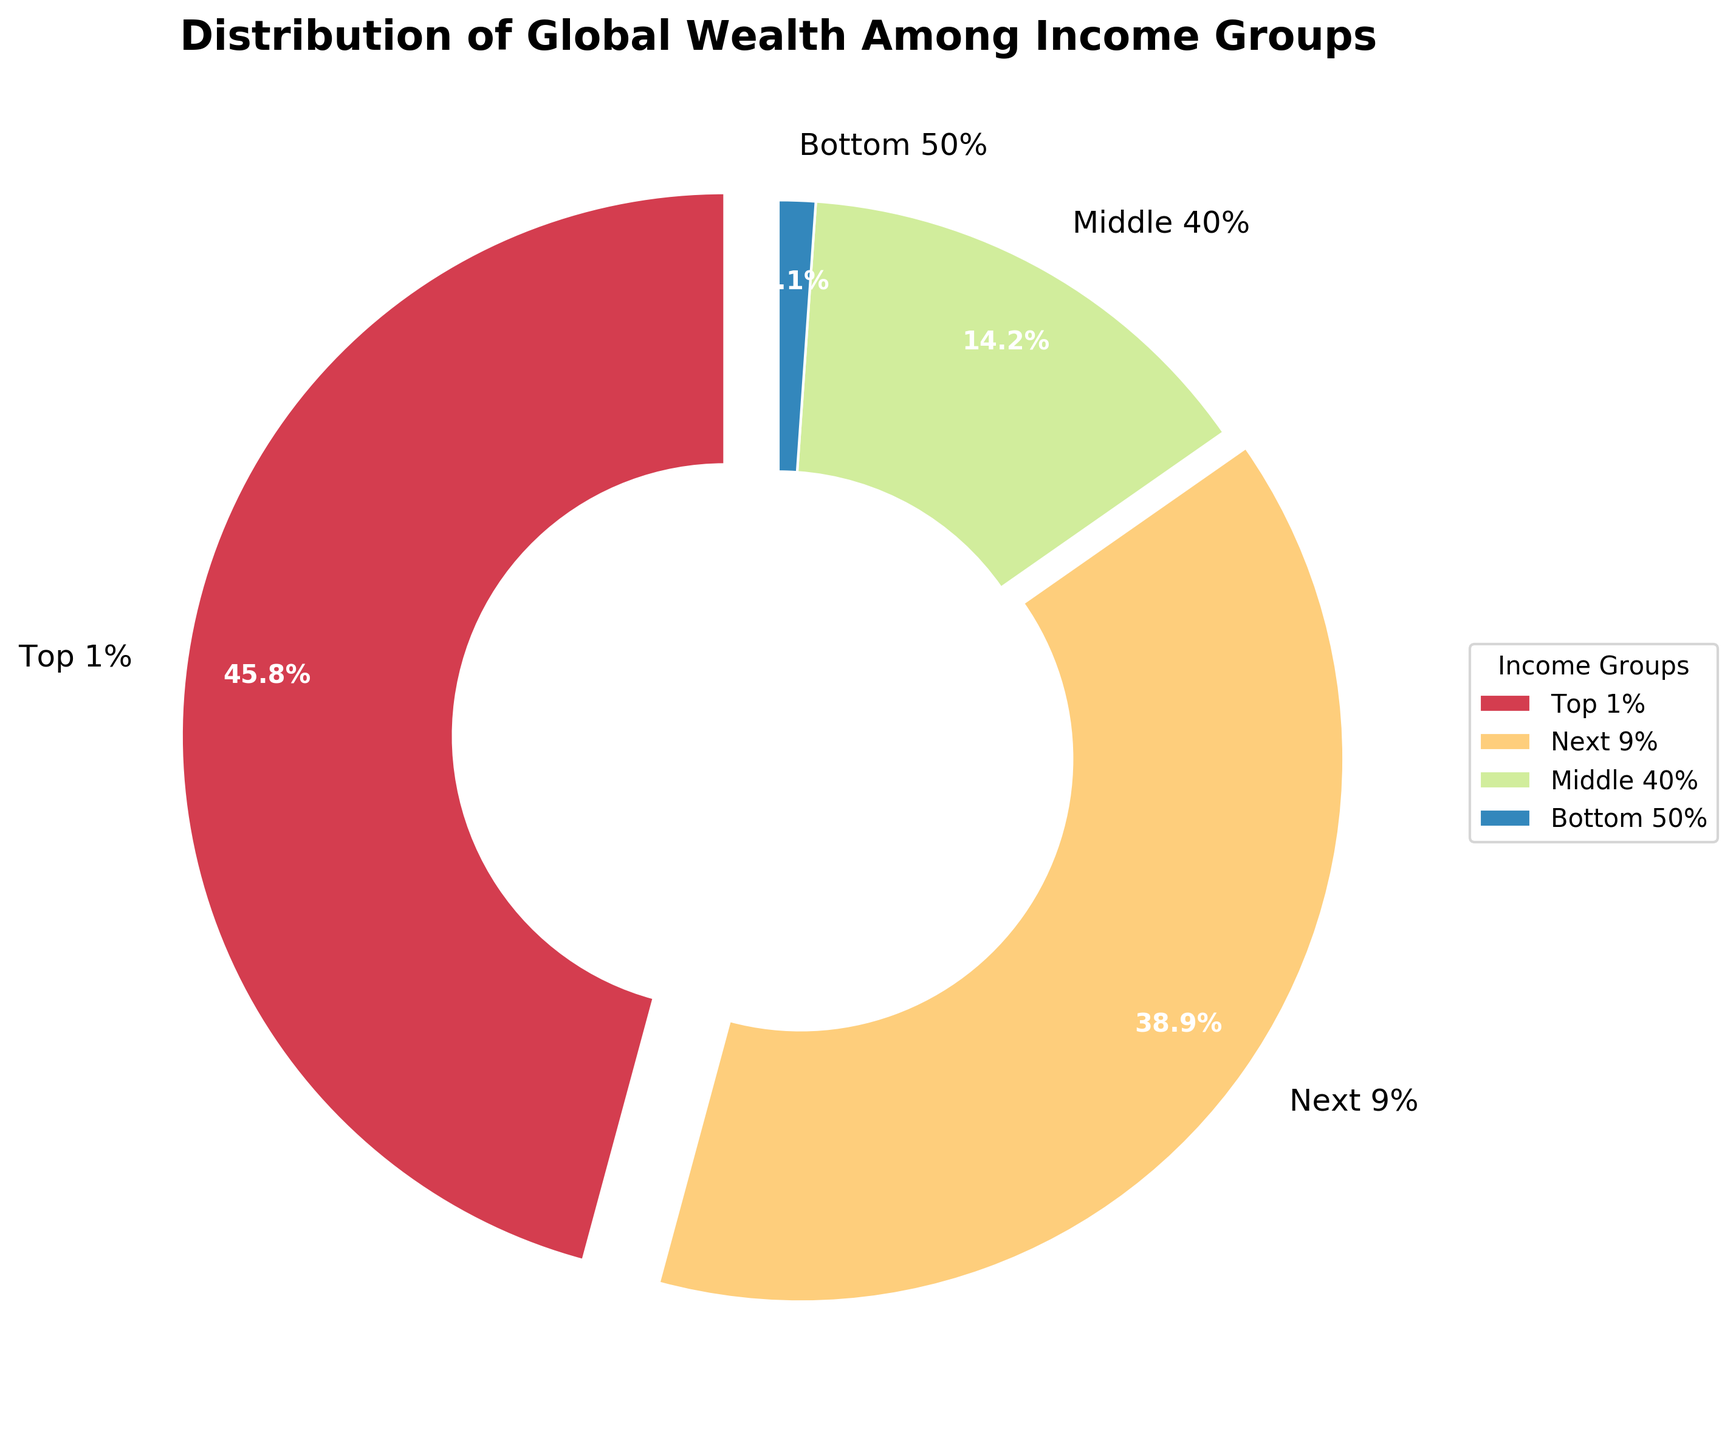What percentage of global wealth does the middle 40% of the population hold? From the pie chart, you can see that the middle 40% of the population holds 14.2% of the global wealth.
Answer: 14.2% Which income group holds the smallest share of global wealth? The bottom 50% of the population holds the smallest share of global wealth, as indicated by the smallest slice in the pie chart at 1.1%.
Answer: Bottom 50% How much more wealth does the top 1% hold compared to the next 9%? The top 1% holds 45.8% of the global wealth, while the next 9% holds 38.9%. The difference is calculated as 45.8 - 38.9 = 6.9 percentage points.
Answer: 6.9 percentage points What is the combined global wealth percentage of the bottom 50% and the middle 40%? The percentages for the bottom 50% and the middle 40% are 1.1% and 14.2% respectively. Adding them together gives 1.1 + 14.2 = 15.3%.
Answer: 15.3% Which group has a larger share of global wealth, the next 9% or the combined bottom 50% and middle 40%? The next 9% holds 38.9% of the global wealth. The combined share of the bottom 50% and middle 40% is 1.1% + 14.2% = 15.3%. Since 38.9% is greater than 15.3%, the next 9% has a larger share of global wealth.
Answer: Next 9% Identify the income groups whose slices are visually distinct due to the explode effect. The slices for both the top 1% and the next 9% have been exploded out of the pie chart slightly, making them visually stand out.
Answer: Top 1% and Next 9% Which income group's global wealth percentage is closest to 40%? The next 9% holds 38.9% of the global wealth, which is closest to 40%.
Answer: Next 9% Describe the color pattern used in the pie chart for the different income groups, starting from the top 1%. The pie chart uses a gradient of colors; starting with the top 1%, the colors move through a spectrum from lighter to darker shades.
Answer: Gradient from lighter to darker shades If you were to combine the top 1% and the next 9%, what portion of global wealth would they hold? Combining the top 1% (45.8%) and the next 9% (38.9%), the total portion of global wealth they hold is 45.8 + 38.9 = 84.7%.
Answer: 84.7% Which income group is represented by the thickest segment in the pie chart? The top 1% has the thickest segment in the pie chart, given its largest share of 45.8% of the global wealth.
Answer: Top 1% 